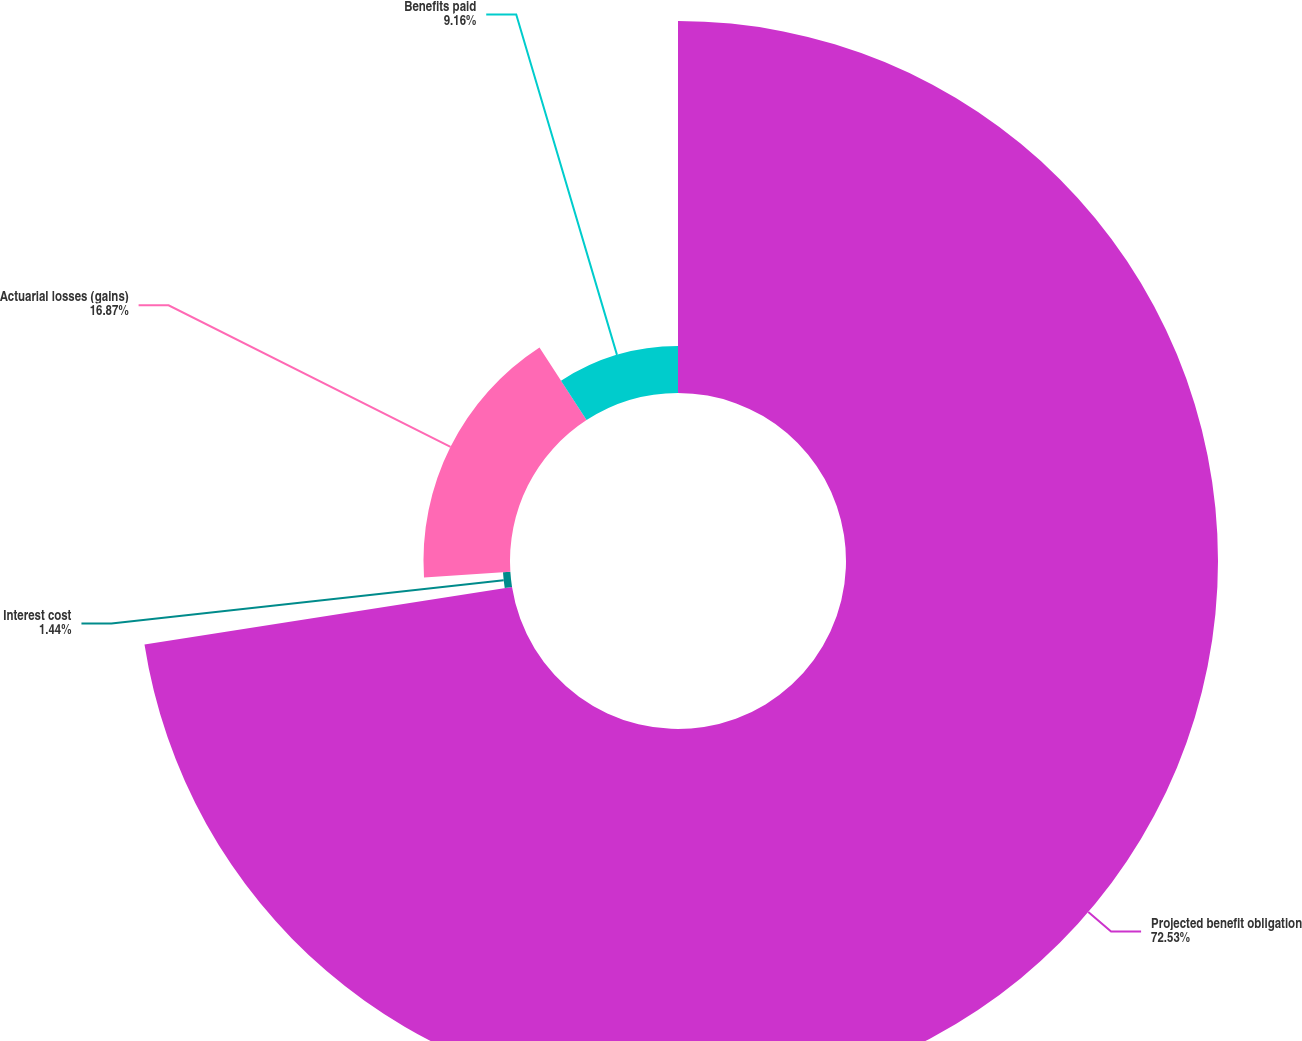Convert chart to OTSL. <chart><loc_0><loc_0><loc_500><loc_500><pie_chart><fcel>Projected benefit obligation<fcel>Interest cost<fcel>Actuarial losses (gains)<fcel>Benefits paid<nl><fcel>72.53%<fcel>1.44%<fcel>16.87%<fcel>9.16%<nl></chart> 